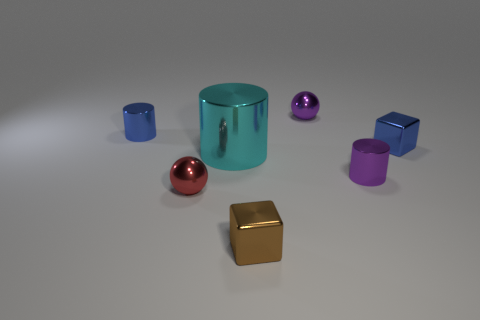Is the number of balls left of the large cyan thing the same as the number of purple cylinders?
Provide a succinct answer. Yes. Is the material of the tiny blue thing that is right of the brown block the same as the tiny brown block?
Offer a very short reply. Yes. Is the number of large cyan shiny cylinders behind the large cyan cylinder less than the number of tiny purple balls?
Give a very brief answer. Yes. How many shiny objects are either large cylinders or tiny red spheres?
Give a very brief answer. 2. Is there anything else that has the same color as the big object?
Give a very brief answer. No. There is a blue shiny thing behind the blue cube; is its shape the same as the tiny purple thing behind the large cyan shiny object?
Provide a short and direct response. No. How many objects are either metal spheres or brown blocks that are in front of the purple metal cylinder?
Your response must be concise. 3. What number of other objects are the same size as the cyan thing?
Your answer should be very brief. 0. Are the sphere that is in front of the big shiny thing and the ball behind the tiny blue block made of the same material?
Provide a succinct answer. Yes. There is a small red metallic object; what number of small purple metallic cylinders are on the left side of it?
Ensure brevity in your answer.  0. 